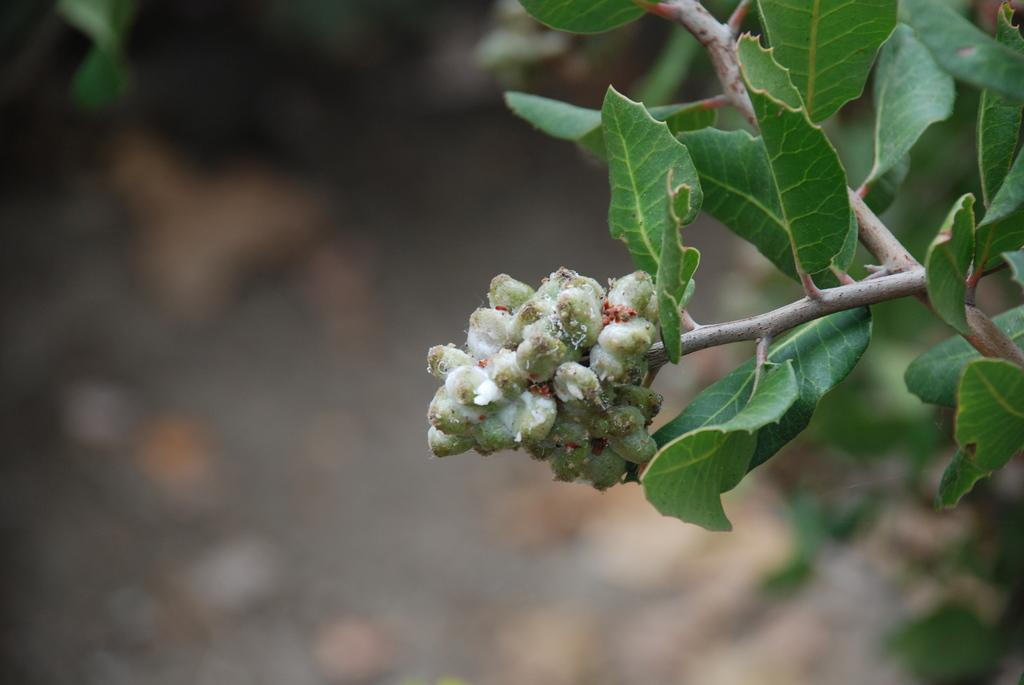What is located on the right side of the image? There is a tree branch on the right side of the image. What can be seen in the center of the image? There are seeds visible in the center of the image. What type of oil is being used to draw the seeds in the image? There is no oil or drawing present in the image; it features a tree branch and seeds. How is the control of the seeds being demonstrated in the image? There is no control or demonstration of the seeds in the image; they are simply visible. 